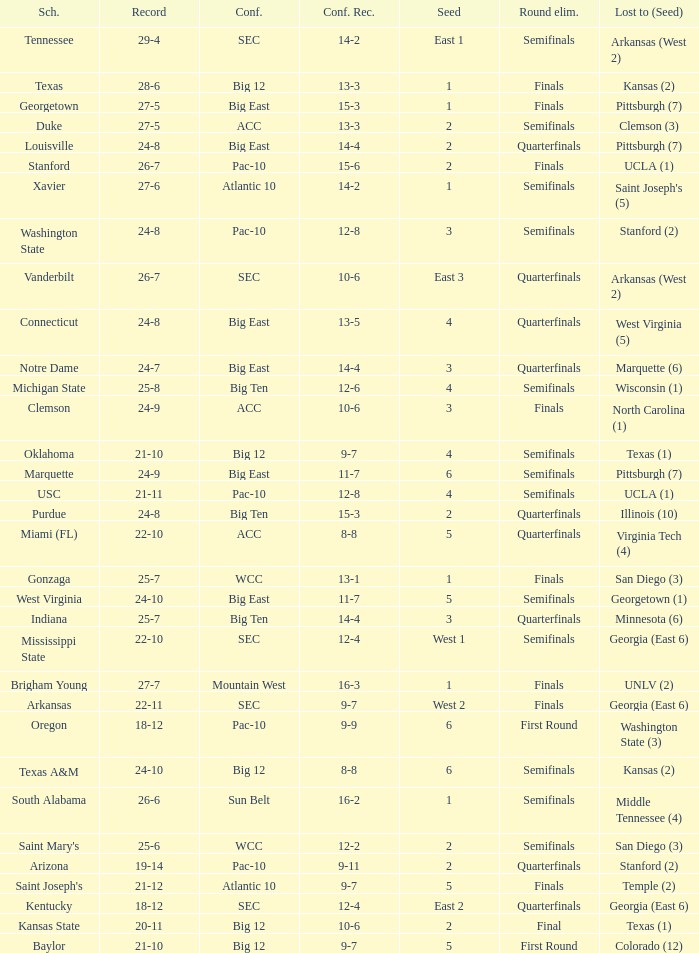Which conference record has a 3 seed and a 24-9 record? 10-6. 